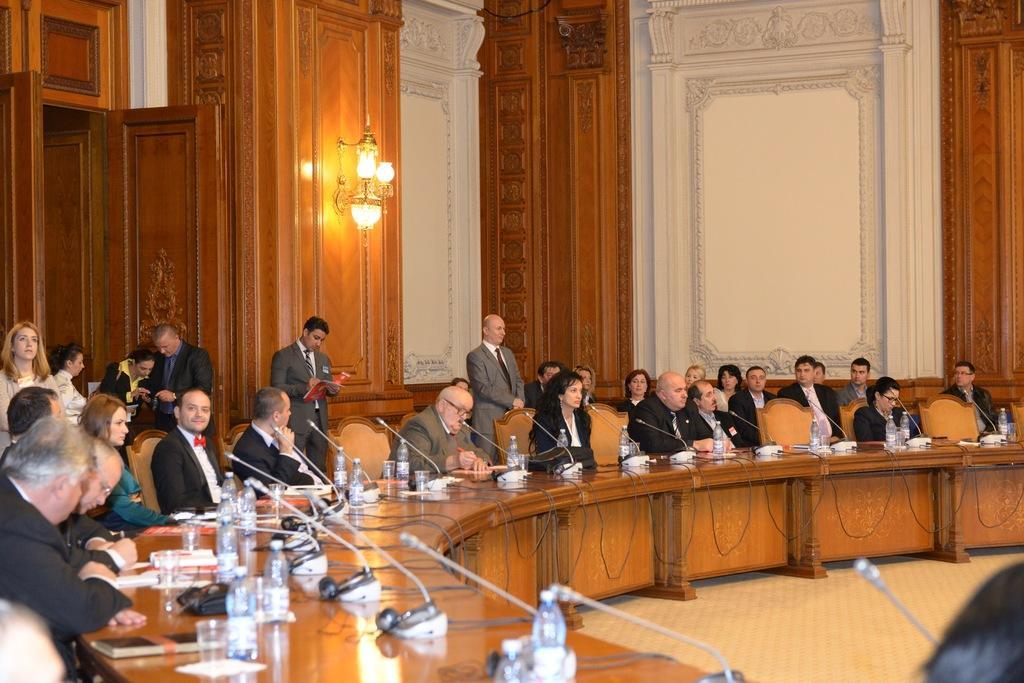In one or two sentences, can you explain what this image depicts? In this image I can see a group of people sitting on the chair. On the table there is bottle,mic,glass and a book. At the background there is alight. 